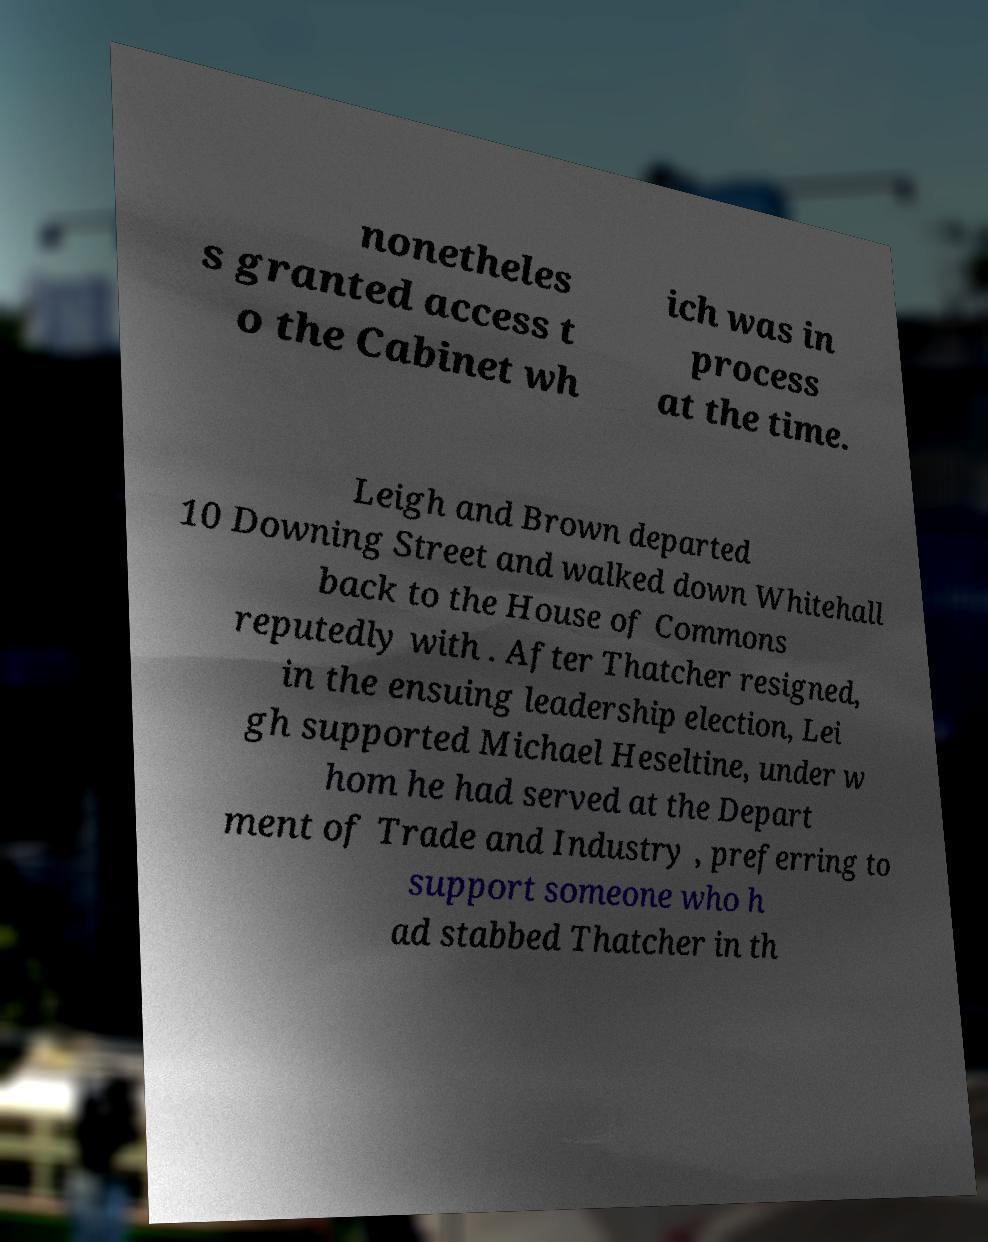Please identify and transcribe the text found in this image. nonetheles s granted access t o the Cabinet wh ich was in process at the time. Leigh and Brown departed 10 Downing Street and walked down Whitehall back to the House of Commons reputedly with . After Thatcher resigned, in the ensuing leadership election, Lei gh supported Michael Heseltine, under w hom he had served at the Depart ment of Trade and Industry , preferring to support someone who h ad stabbed Thatcher in th 